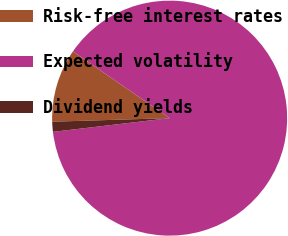Convert chart. <chart><loc_0><loc_0><loc_500><loc_500><pie_chart><fcel>Risk-free interest rates<fcel>Expected volatility<fcel>Dividend yields<nl><fcel>10.09%<fcel>88.53%<fcel>1.38%<nl></chart> 